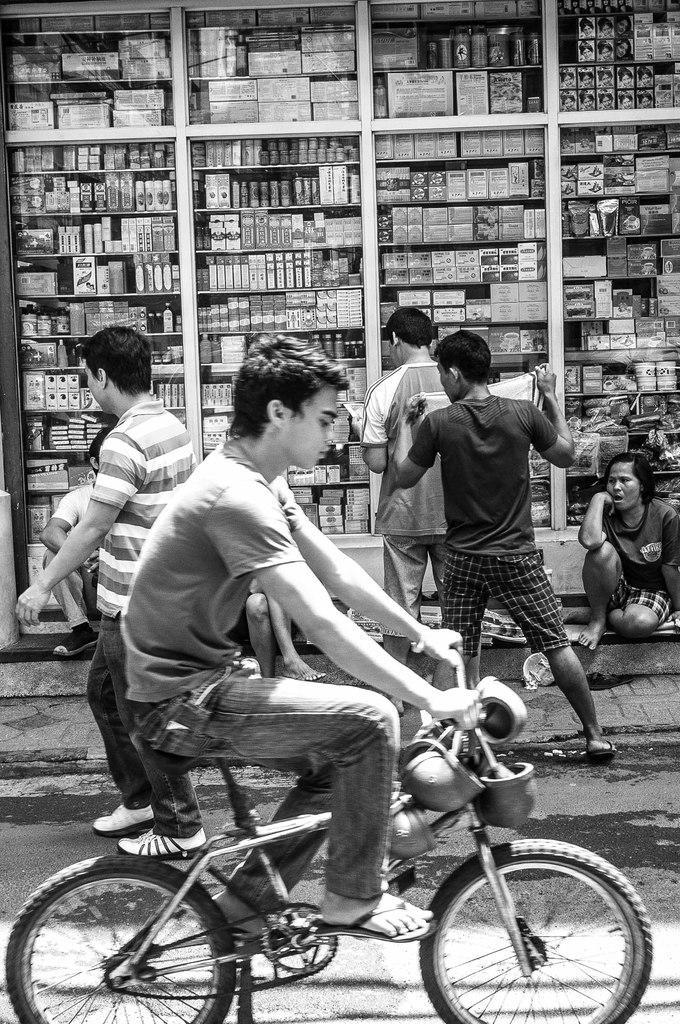In one or two sentences, can you explain what this image depicts? This is a black and white picture, a man is riding a bicycle. Behind the man there are group of people are standing on the road and a shelf. On the shelf there are lot of items. 